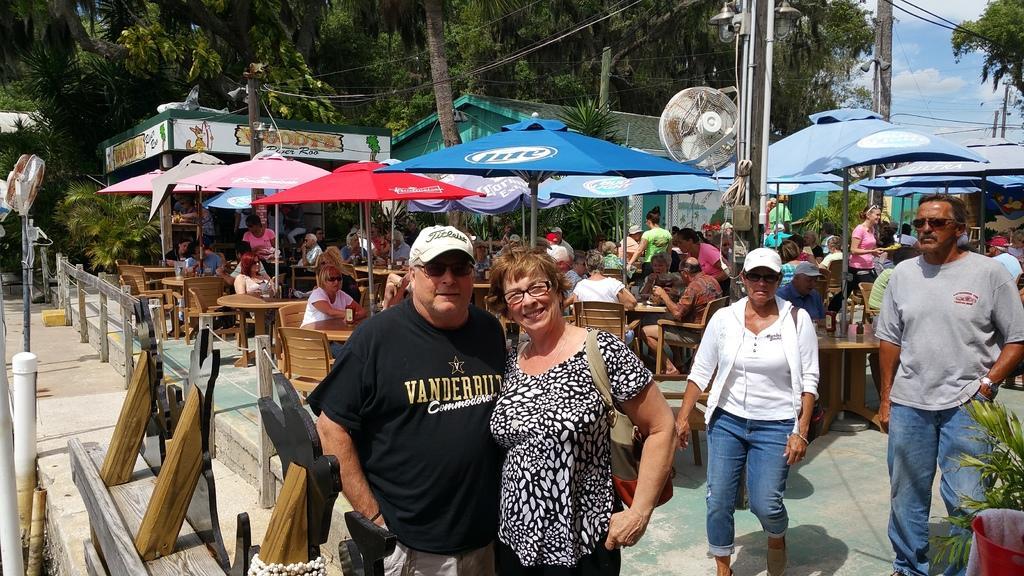Could you give a brief overview of what you see in this image? In the center of the image we can see people standing and some of them are walking. In the background there are tables and chairs. There are many people sitting. We can see parasols. In the background there are sheds, trees, poles and sky. 